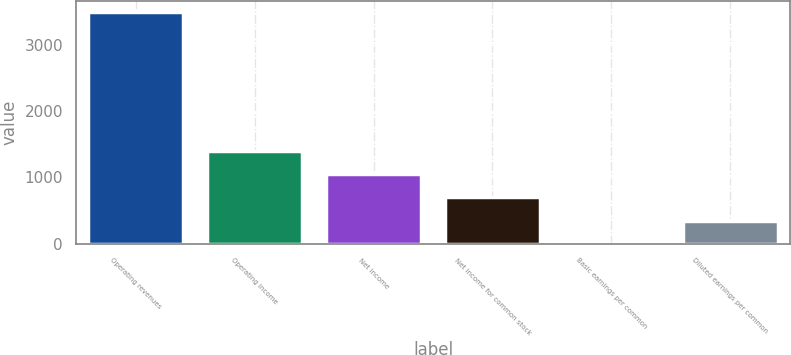<chart> <loc_0><loc_0><loc_500><loc_500><bar_chart><fcel>Operating revenues<fcel>Operating income<fcel>Net income<fcel>Net income for common stock<fcel>Basic earnings per common<fcel>Diluted earnings per common<nl><fcel>3489<fcel>1396.34<fcel>1047.56<fcel>698.78<fcel>1.22<fcel>350<nl></chart> 